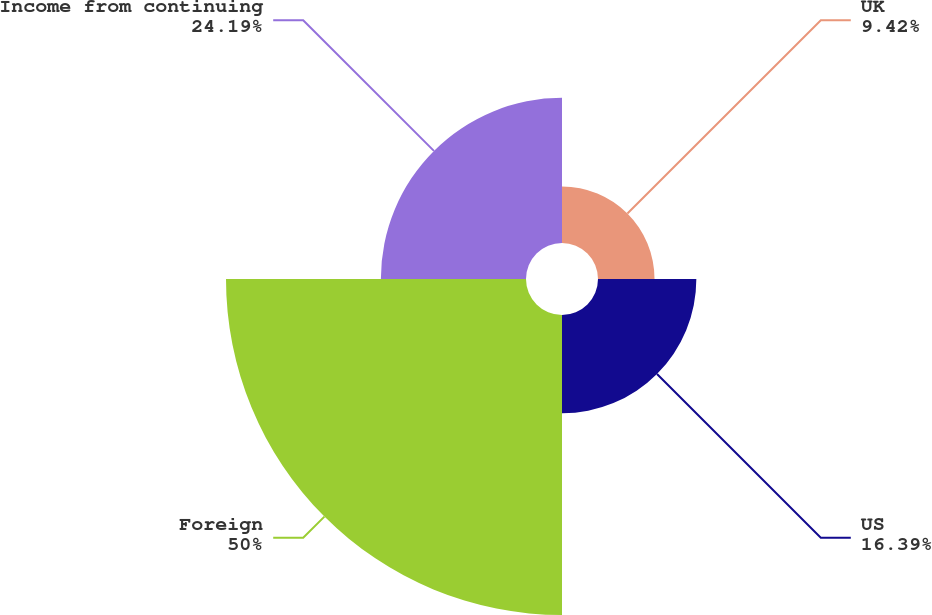<chart> <loc_0><loc_0><loc_500><loc_500><pie_chart><fcel>UK<fcel>US<fcel>Foreign<fcel>Income from continuing<nl><fcel>9.42%<fcel>16.39%<fcel>50.0%<fcel>24.19%<nl></chart> 